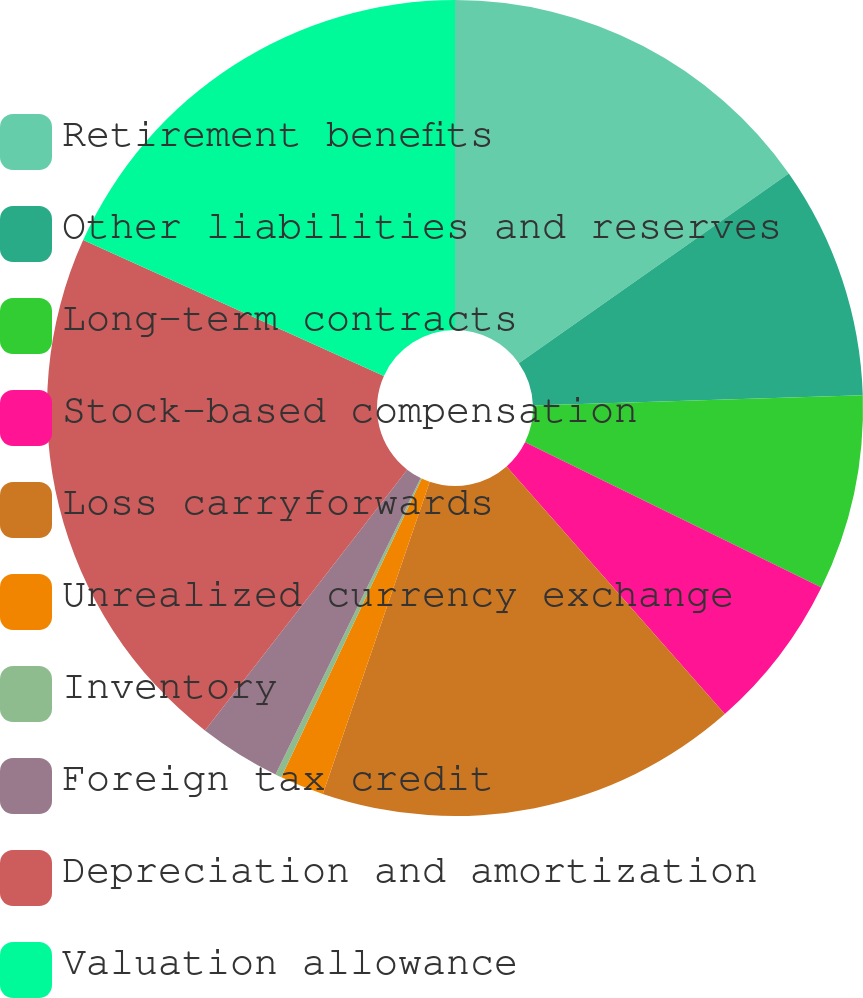Convert chart. <chart><loc_0><loc_0><loc_500><loc_500><pie_chart><fcel>Retirement benefits<fcel>Other liabilities and reserves<fcel>Long-term contracts<fcel>Stock-based compensation<fcel>Loss carryforwards<fcel>Unrealized currency exchange<fcel>Inventory<fcel>Foreign tax credit<fcel>Depreciation and amortization<fcel>Valuation allowance<nl><fcel>15.25%<fcel>9.25%<fcel>7.75%<fcel>6.25%<fcel>16.75%<fcel>1.75%<fcel>0.25%<fcel>3.25%<fcel>21.25%<fcel>18.25%<nl></chart> 